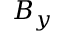Convert formula to latex. <formula><loc_0><loc_0><loc_500><loc_500>B _ { y }</formula> 